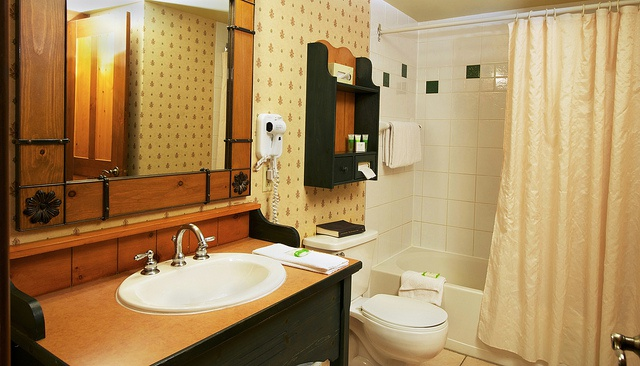Describe the objects in this image and their specific colors. I can see sink in black, beige, orange, and red tones, toilet in black, beige, tan, and olive tones, book in black, tan, and olive tones, and hair drier in black, lightgray, and tan tones in this image. 